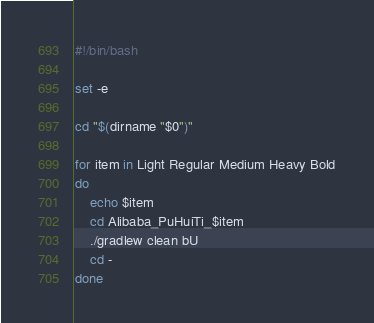Convert code to text. <code><loc_0><loc_0><loc_500><loc_500><_Bash_>#!/bin/bash

set -e

cd "$(dirname "$0")"

for item in Light Regular Medium Heavy Bold
do
    echo $item
    cd Alibaba_PuHuiTi_$item
    ./gradlew clean bU
    cd -
done
</code> 